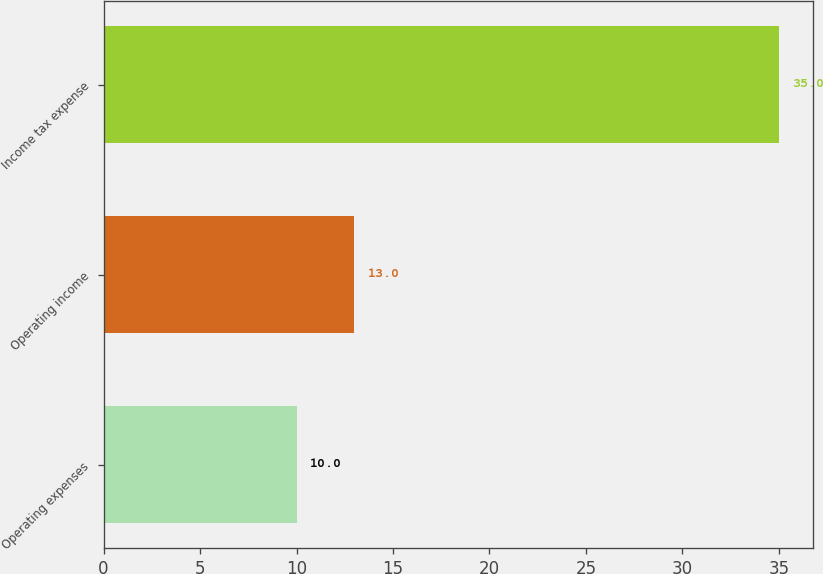Convert chart. <chart><loc_0><loc_0><loc_500><loc_500><bar_chart><fcel>Operating expenses<fcel>Operating income<fcel>Income tax expense<nl><fcel>10<fcel>13<fcel>35<nl></chart> 